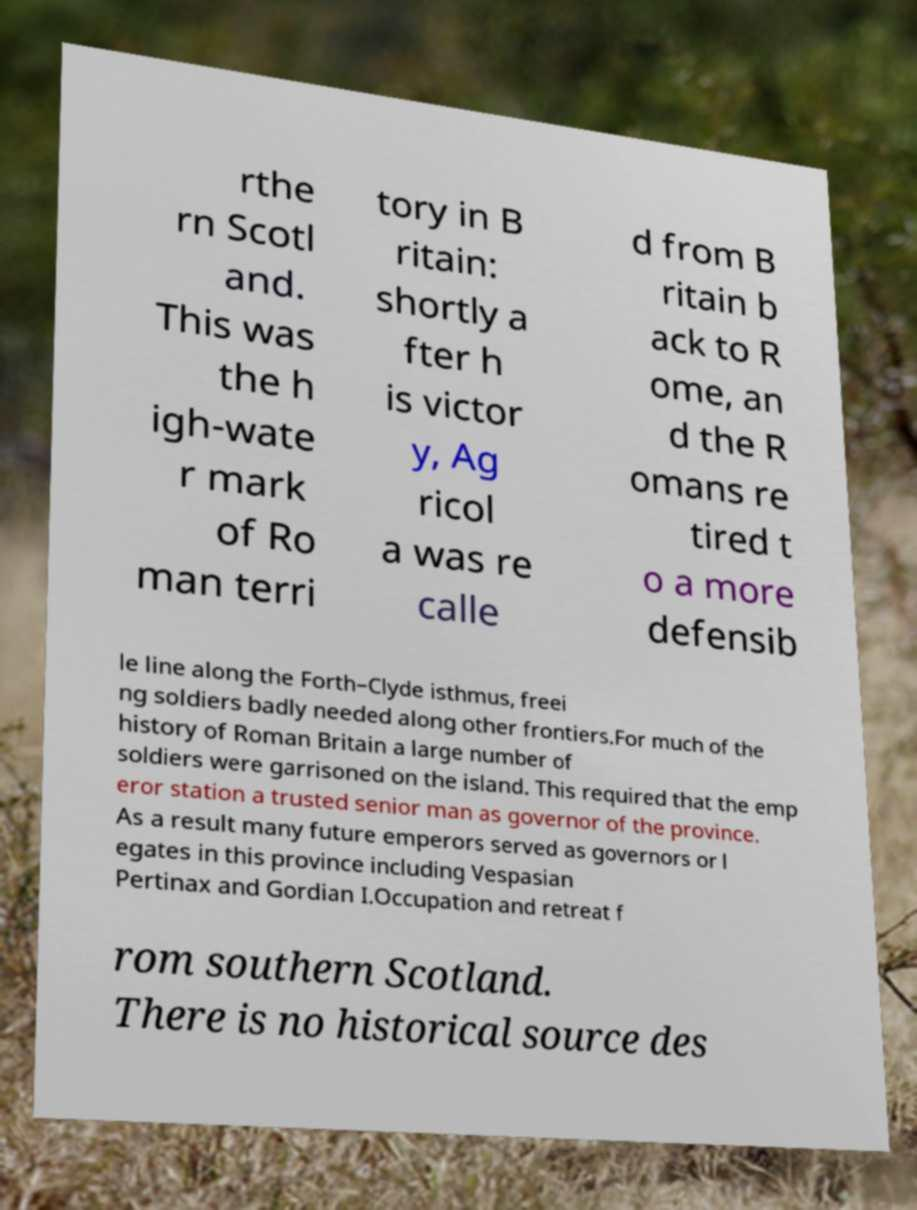For documentation purposes, I need the text within this image transcribed. Could you provide that? rthe rn Scotl and. This was the h igh-wate r mark of Ro man terri tory in B ritain: shortly a fter h is victor y, Ag ricol a was re calle d from B ritain b ack to R ome, an d the R omans re tired t o a more defensib le line along the Forth–Clyde isthmus, freei ng soldiers badly needed along other frontiers.For much of the history of Roman Britain a large number of soldiers were garrisoned on the island. This required that the emp eror station a trusted senior man as governor of the province. As a result many future emperors served as governors or l egates in this province including Vespasian Pertinax and Gordian I.Occupation and retreat f rom southern Scotland. There is no historical source des 